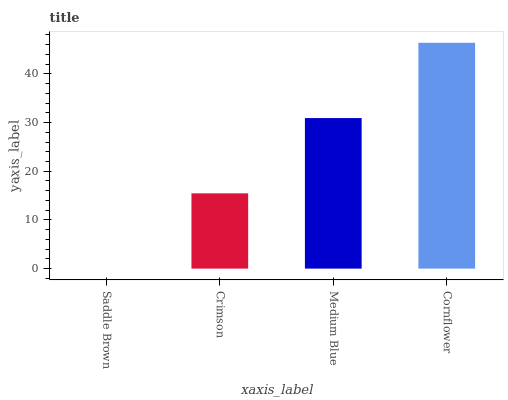Is Crimson the minimum?
Answer yes or no. No. Is Crimson the maximum?
Answer yes or no. No. Is Crimson greater than Saddle Brown?
Answer yes or no. Yes. Is Saddle Brown less than Crimson?
Answer yes or no. Yes. Is Saddle Brown greater than Crimson?
Answer yes or no. No. Is Crimson less than Saddle Brown?
Answer yes or no. No. Is Medium Blue the high median?
Answer yes or no. Yes. Is Crimson the low median?
Answer yes or no. Yes. Is Cornflower the high median?
Answer yes or no. No. Is Cornflower the low median?
Answer yes or no. No. 